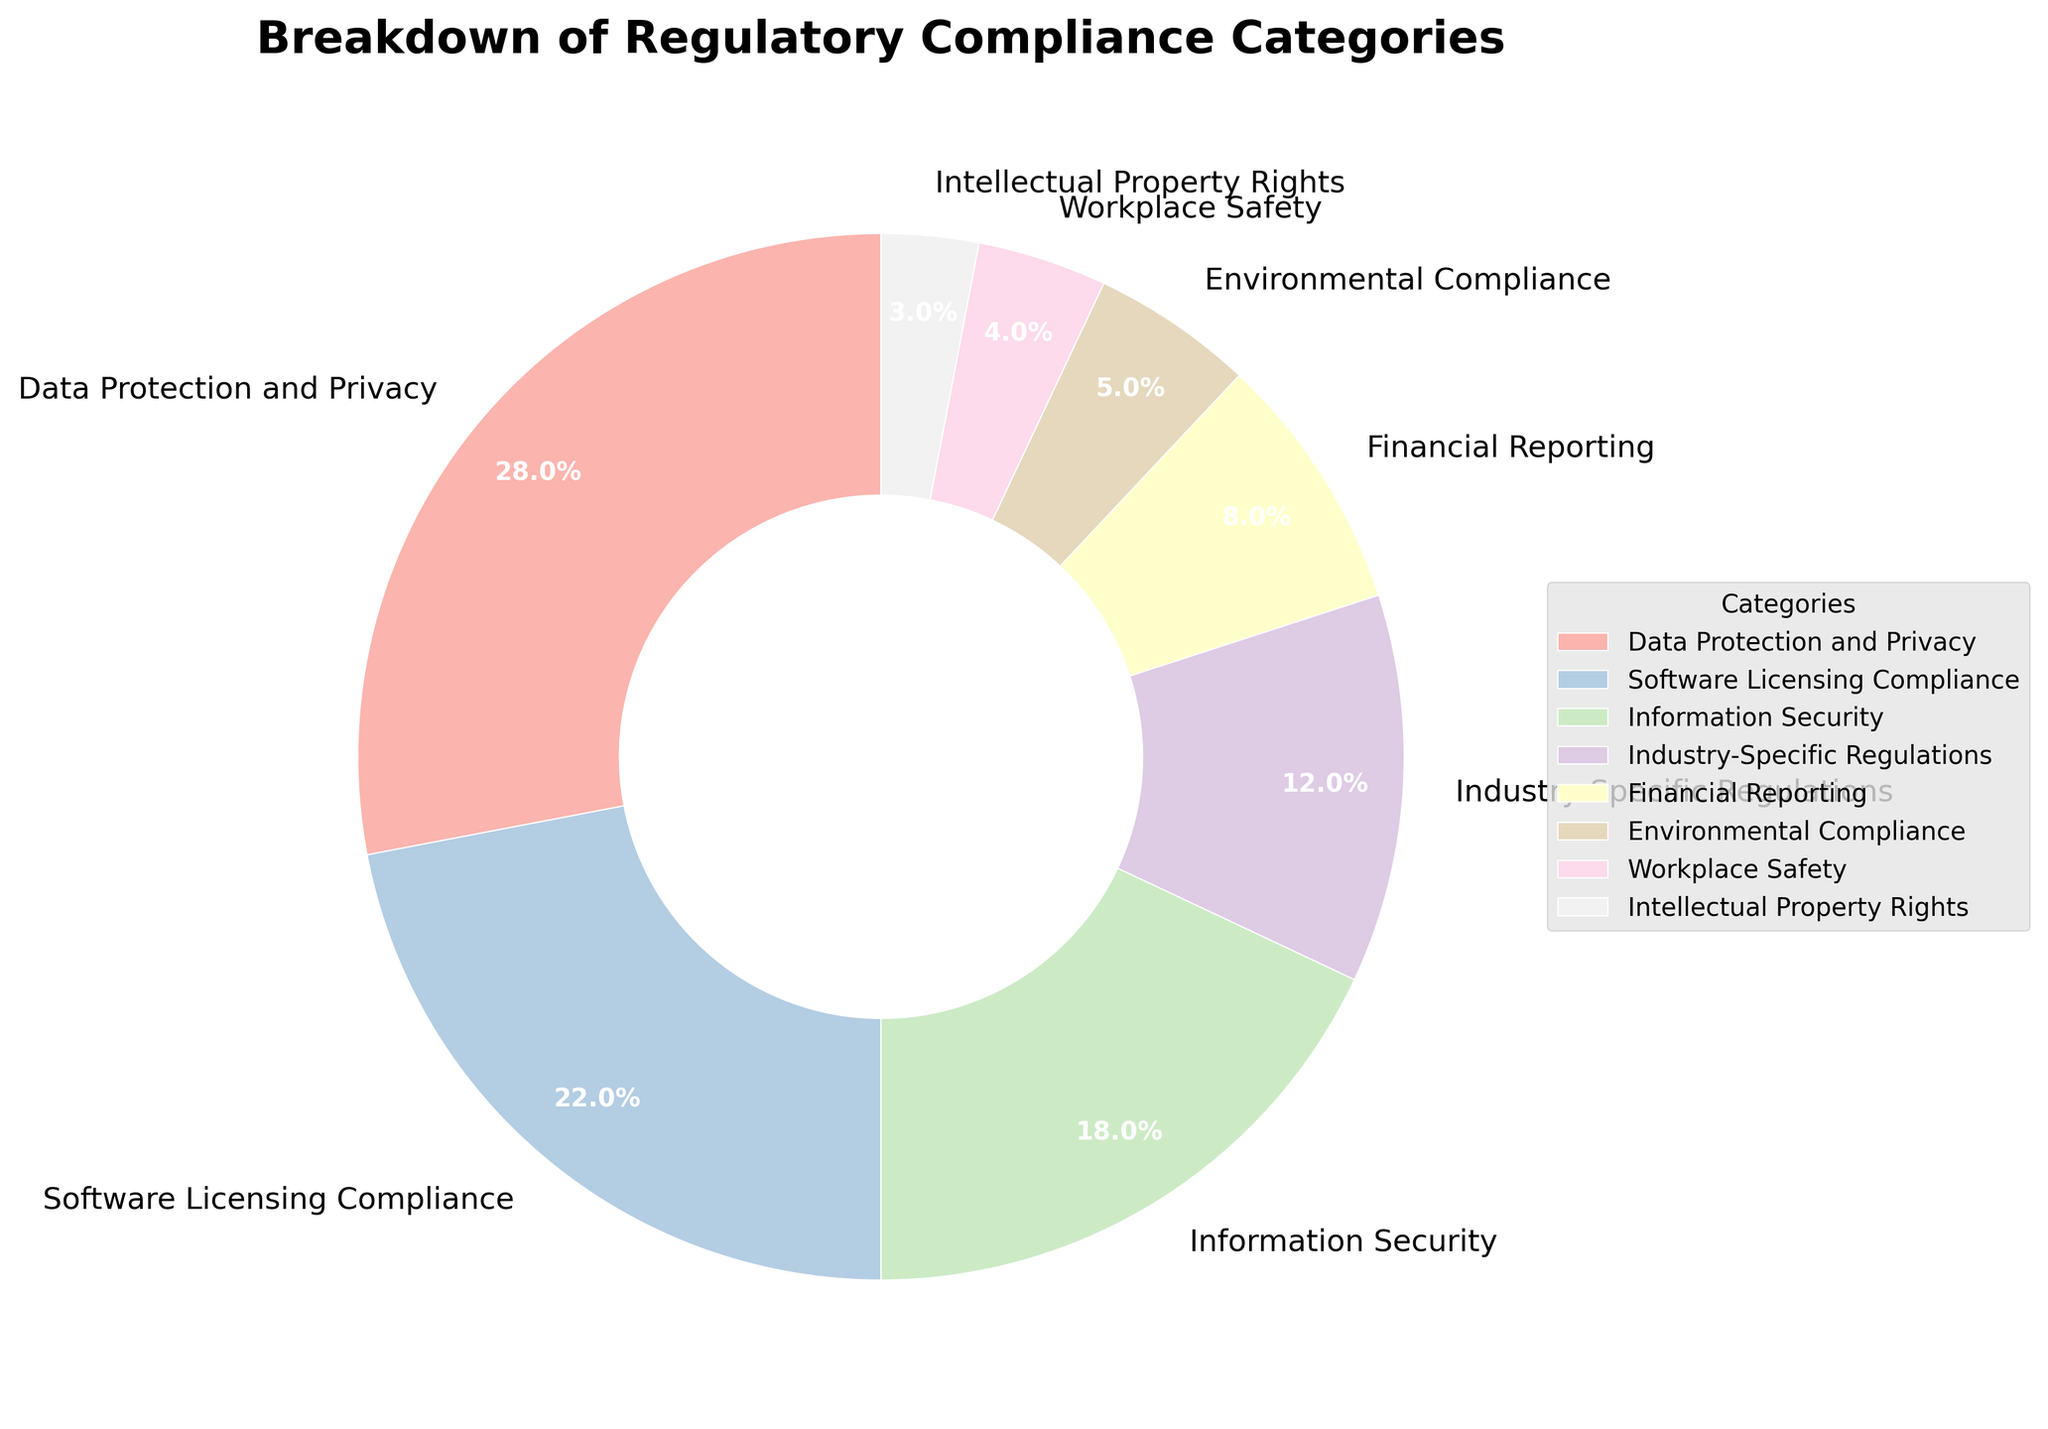What category has the highest percentage of regulatory compliance? The pie chart displays the percentages for each category. Data Protection and Privacy has the highest percentage at 28%.
Answer: Data Protection and Privacy What percentage of regulatory compliance is related to Information Security? From the pie chart, Information Security is shown to comprise 18% of the total regulatory compliance.
Answer: 18% Which category has a lower percentage, Financial Reporting or Environmental Compliance? According to the pie chart, Financial Reporting has 8%, while Environmental Compliance has 5%. Thus, Environmental Compliance has a lower percentage.
Answer: Environmental Compliance What is the combined percentage of Industry-Specific Regulations and Workplace Safety? Adding the percentages of Industry-Specific Regulations (12%) and Workplace Safety (4%) results in a combined percentage of 16%.
Answer: 16% Are there more categories with a percentage above 15% or below 15%? Categories above 15%: Data Protection and Privacy (28%), Software Licensing Compliance (22%), Information Security (18%). Categories below 15%: Industry-Specific Regulations (12%), Financial Reporting (8%), Environmental Compliance (5%), Workplace Safety (4%), Intellectual Property Rights (3%). There are 3 categories above and 5 below.
Answer: Below 15% What is the percentage difference between Software Licensing Compliance and Intellectual Property Rights? Subtracting the percentage of Intellectual Property Rights (3%) from Software Licensing Compliance (22%) gives a difference of 19%.
Answer: 19% Which category has the smallest wedge and what is its percentage? The smallest wedge in the pie chart belongs to Intellectual Property Rights with a percentage of 3%.
Answer: Intellectual Property Rights, 3% How much greater is the percentage for Data Protection and Privacy compared to Financial Reporting? The percentage for Data Protection and Privacy is 28% and for Financial Reporting is 8%. The difference is 28% - 8% = 20%.
Answer: 20% What is the total percentage of categories related to software and security (Software Licensing Compliance and Information Security)? Software Licensing Compliance has 22% and Information Security has 18%, summing up to 22% + 18% = 40%.
Answer: 40% How many categories have a percentage greater than or equal to 10%? From the pie chart, Data Protection and Privacy (28%), Software Licensing Compliance (22%), Information Security (18%), and Industry-Specific Regulations (12%) all have percentages above 10%. There are 4 such categories.
Answer: 4 categories 